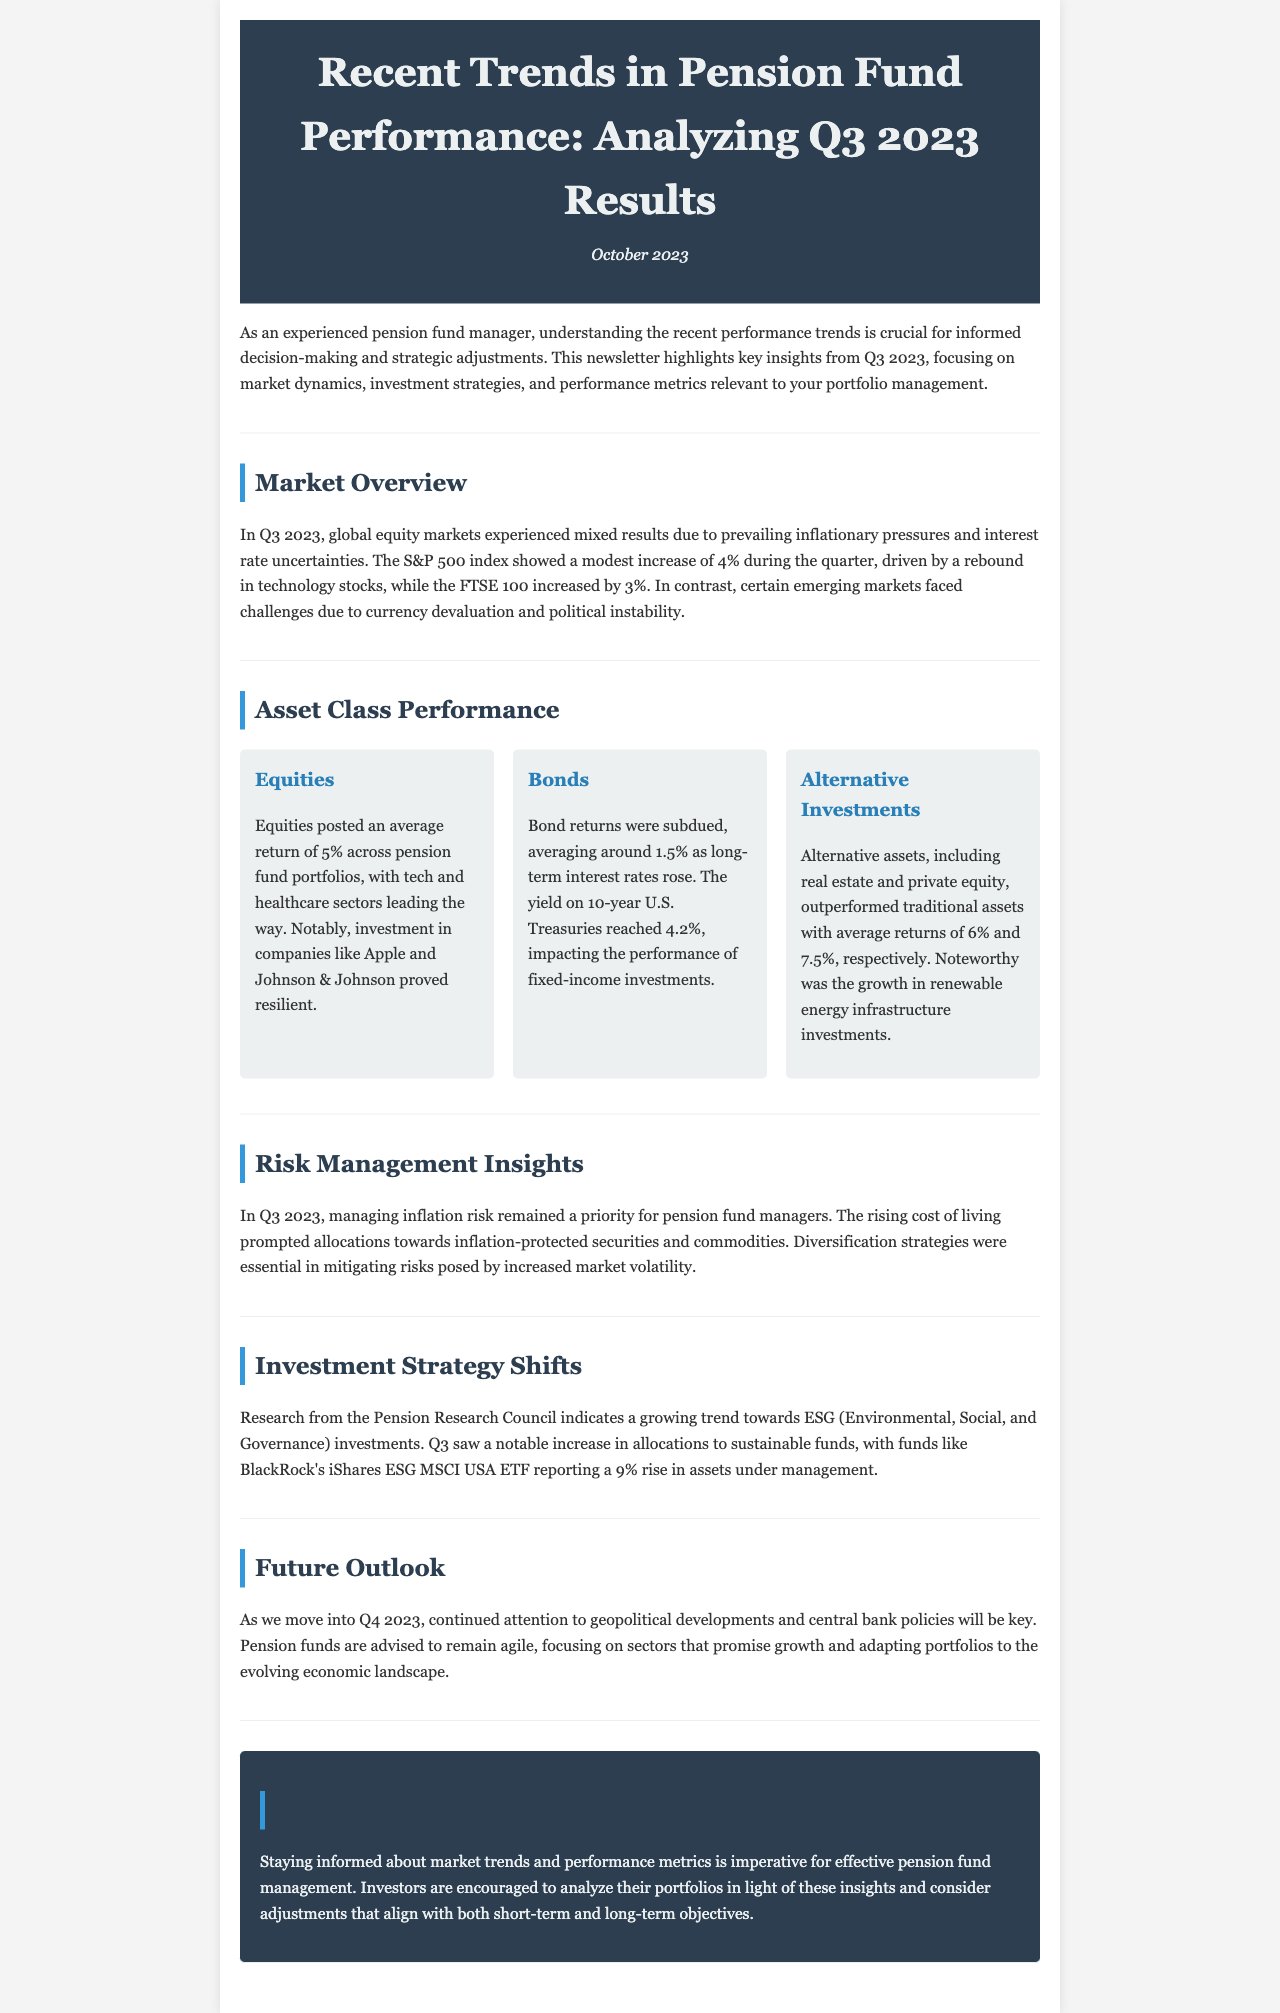What was the average return of equities in Q3 2023? The average return of equities in Q3 2023 across pension fund portfolios was 5%.
Answer: 5% What percentage increase did the S&P 500 experience in Q3 2023? The S&P 500 index experienced a modest increase of 4% during the quarter.
Answer: 4% Which sectors led the way in equity performance? The tech and healthcare sectors led the way in equity performance, with a focus on companies like Apple and Johnson & Johnson.
Answer: Tech and healthcare What was the average return of alternative assets in Q3 2023? Alternative assets posted an average return of 6% and 7.5% for real estate and private equity, respectively.
Answer: 6% and 7.5% Why did pension fund managers prioritize inflation risk management? The rising cost of living prompted allocations towards inflation-protected securities and commodities.
Answer: Rising cost of living What was the yield on 10-year U.S. Treasuries in Q3 2023? The yield on 10-year U.S. Treasuries reached 4.2%.
Answer: 4.2% What trend is observed in investment strategies according to the Pension Research Council? There is a growing trend towards ESG (Environmental, Social, and Governance) investments.
Answer: ESG investments What was the increase in assets under management reported by BlackRock's iShares ESG MSCI USA ETF in Q3 2023? BlackRock's iShares ESG MSCI USA ETF reported a 9% rise in assets under management.
Answer: 9% 